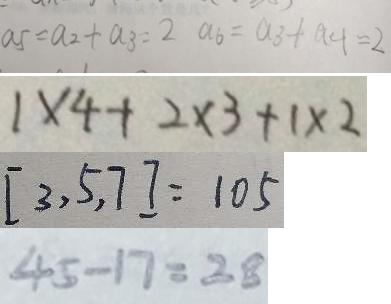Convert formula to latex. <formula><loc_0><loc_0><loc_500><loc_500>a 5 = a _ { 2 } + a _ { 3 } = 2 a _ { 6 } = a _ { 3 } + a _ { 4 } = 2 
 = 1 \times 4 + 2 \times 3 + 1 \times 2 
 [ 3 , 5 , 7 ] = 1 0 5 
 4 5 - 1 7 = 2 8</formula> 